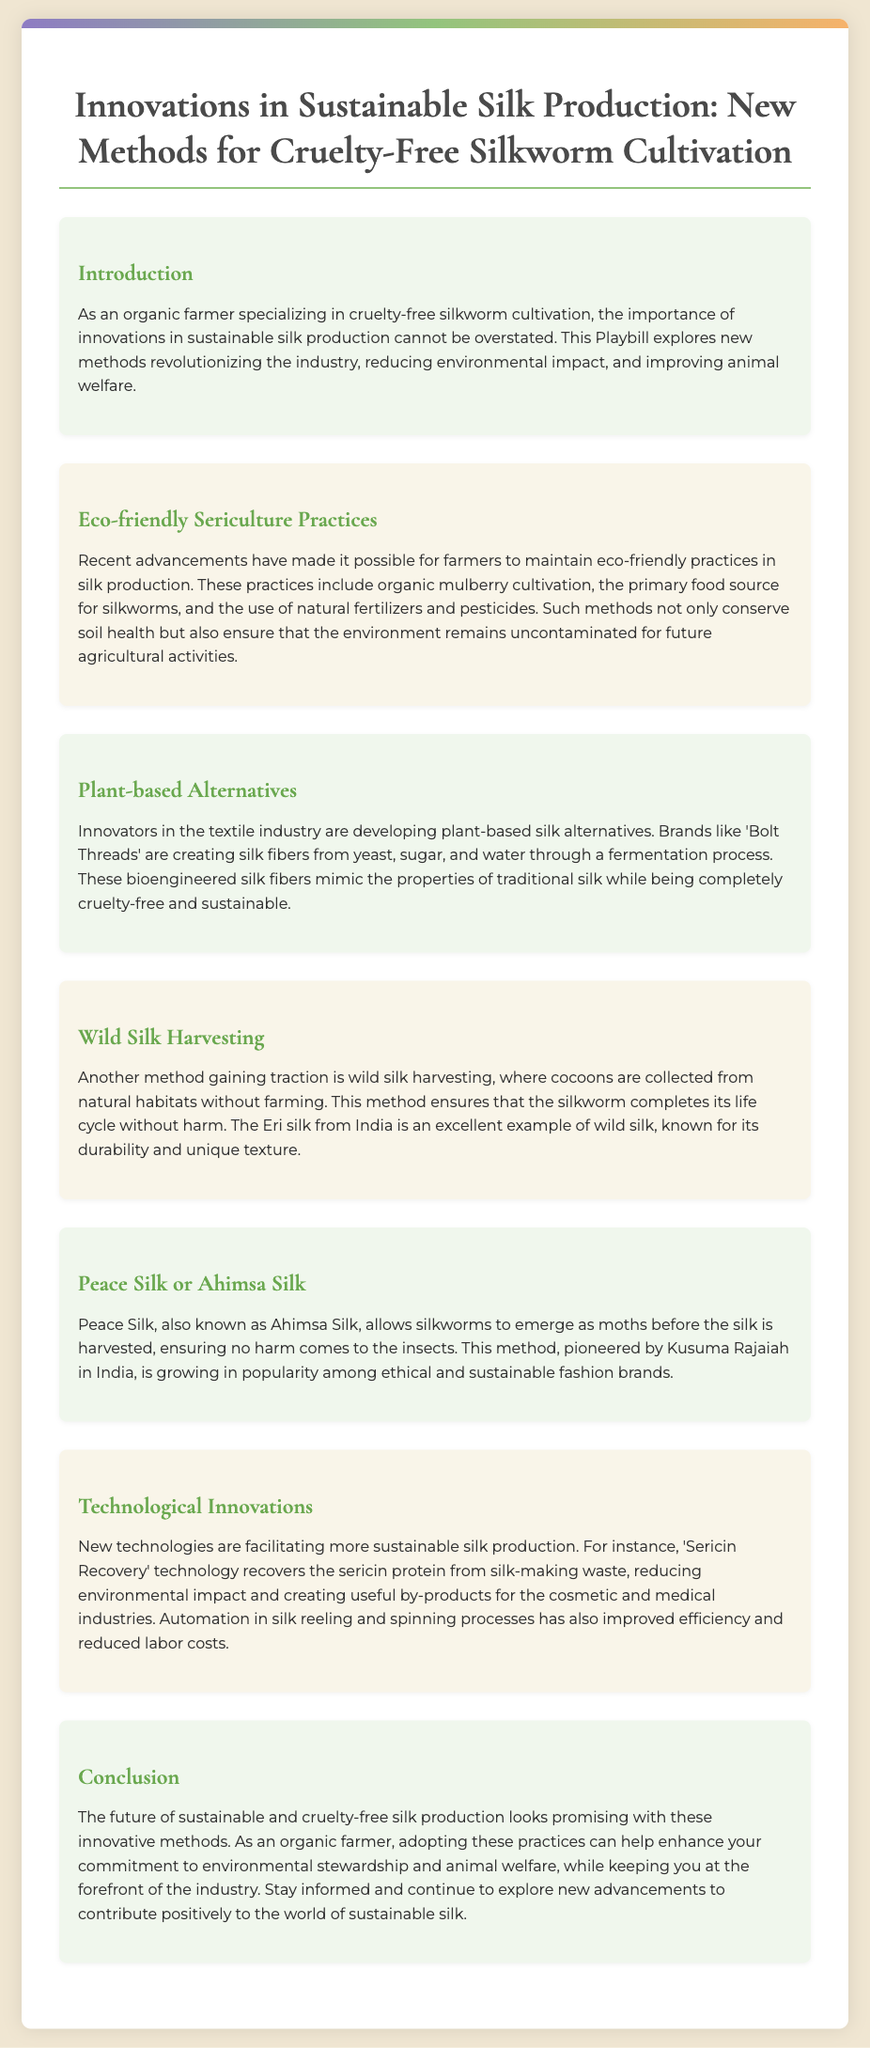what is the title of the Playbill? The title of the Playbill is presented at the top of the document.
Answer: Innovations in Sustainable Silk Production: New Methods for Cruelty-Free Silkworm Cultivation who pioneered the Peace Silk method? The document states that the method was pioneered by a specific individual in India.
Answer: Kusuma Rajaiah what is a key practice in eco-friendly sericulture? The document lists important practices in sustainable silk production.
Answer: Organic mulberry cultivation what is Eri silk known for? Eri silk is mentioned in the context of wild silk harvesting and its characteristics.
Answer: Durability and unique texture how many sections are in the Playbill? The document outlines the different parts of the Playbill.
Answer: Six sections what technology is mentioned for recovering silk-making waste? The document describes a specific technology related to silk production.
Answer: Sericin Recovery which brand is noted for developing plant-based silk alternatives? The document refers to a particular brand in the textile industry creating alternatives.
Answer: Bolt Threads what is another name for Ahimsa Silk? The term name is mentioned within the context of the discussion on ethical practices.
Answer: Peace Silk 